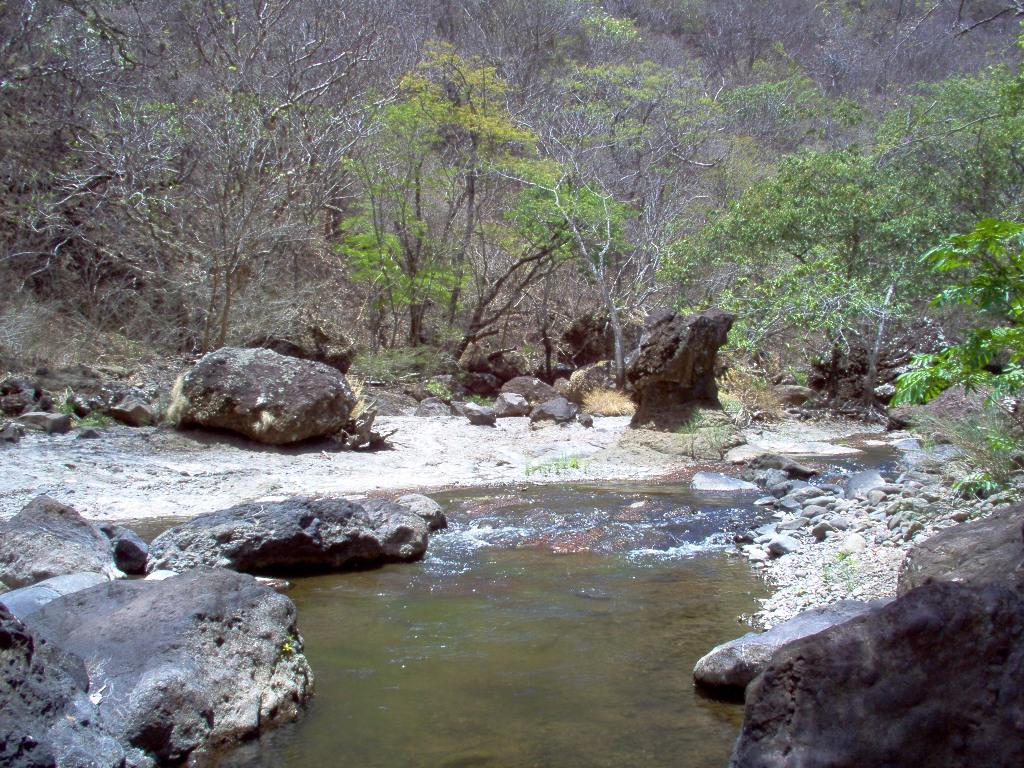What is the primary element visible in the image? There is water in the image. What other objects or features can be seen in the image? There are rocks in the image. What can be seen in the background of the image? There are trees in the background of the image. What type of loaf is being used to create ripples in the water? There is no loaf present in the image, and therefore no ripples are being created by a loaf. 